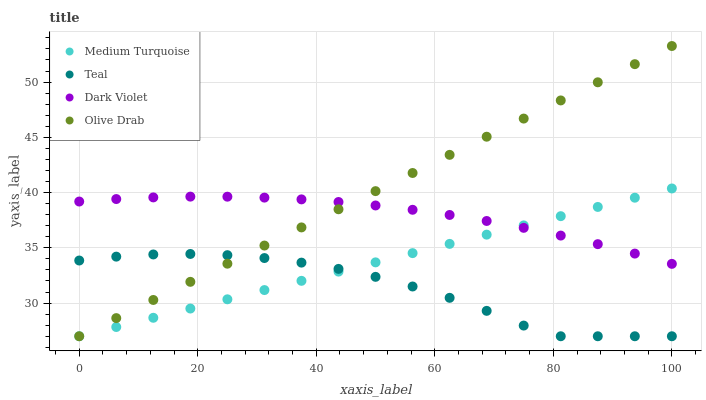Does Teal have the minimum area under the curve?
Answer yes or no. Yes. Does Olive Drab have the maximum area under the curve?
Answer yes or no. Yes. Does Dark Violet have the minimum area under the curve?
Answer yes or no. No. Does Dark Violet have the maximum area under the curve?
Answer yes or no. No. Is Medium Turquoise the smoothest?
Answer yes or no. Yes. Is Teal the roughest?
Answer yes or no. Yes. Is Dark Violet the smoothest?
Answer yes or no. No. Is Dark Violet the roughest?
Answer yes or no. No. Does Olive Drab have the lowest value?
Answer yes or no. Yes. Does Dark Violet have the lowest value?
Answer yes or no. No. Does Olive Drab have the highest value?
Answer yes or no. Yes. Does Dark Violet have the highest value?
Answer yes or no. No. Is Teal less than Dark Violet?
Answer yes or no. Yes. Is Dark Violet greater than Teal?
Answer yes or no. Yes. Does Teal intersect Medium Turquoise?
Answer yes or no. Yes. Is Teal less than Medium Turquoise?
Answer yes or no. No. Is Teal greater than Medium Turquoise?
Answer yes or no. No. Does Teal intersect Dark Violet?
Answer yes or no. No. 